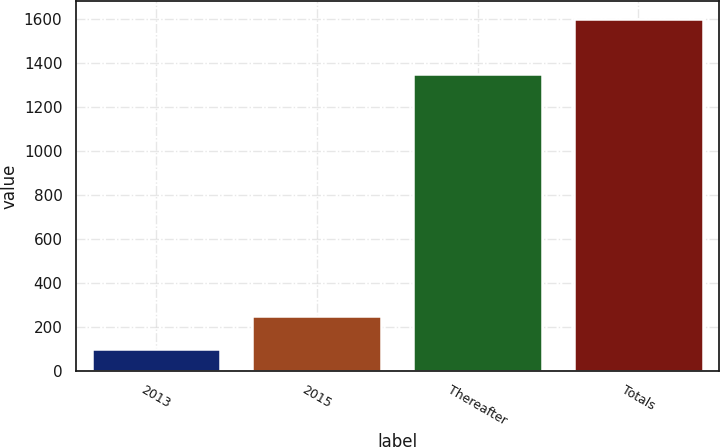Convert chart. <chart><loc_0><loc_0><loc_500><loc_500><bar_chart><fcel>2013<fcel>2015<fcel>Thereafter<fcel>Totals<nl><fcel>100<fcel>250<fcel>1350<fcel>1600<nl></chart> 